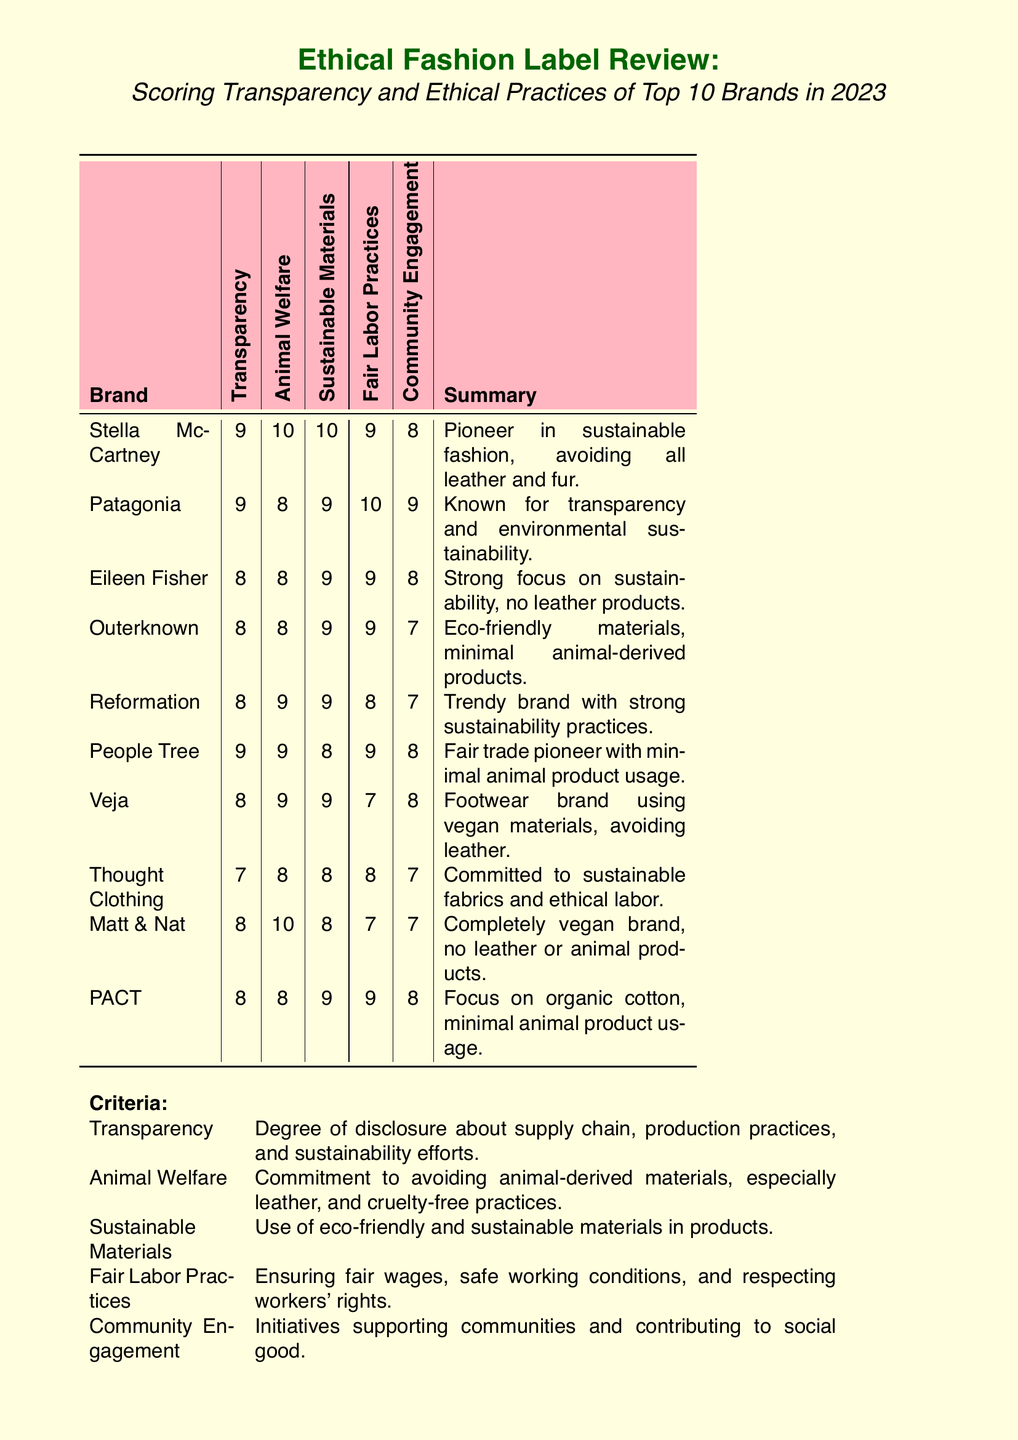What is the highest score for Animal Welfare? The highest score for Animal Welfare among the brands listed in the document is 10, awarded to Stella McCartney and Matt & Nat.
Answer: 10 Which brand is a pioneer in sustainable fashion? The document states that Stella McCartney is a pioneer in sustainable fashion, making it clear in the summary provided.
Answer: Stella McCartney What is the average score for Sustainable Materials among the brands listed? By averaging the scores for Sustainable Materials: (10+9+9+9+9+8+9+8+9+8) / 10 = 8.9.
Answer: 8.9 Which brand uses completely vegan materials and avoids leather? The document specifies that Matt & Nat is a completely vegan brand with no leather or animal products.
Answer: Matt & Nat What does the score for Fair Labor Practices of Patagonia indicate? Patagonia's score for Fair Labor Practices is 10, indicating excellent fair labor practices according to the scoring criteria.
Answer: 10 How many brands scored an 8 for Transparency? The document shows that 5 brands scored an 8 for Transparency: Eileen Fisher, Outerknown, Reformation, Veja, and PACT.
Answer: 5 What criteria has a score of 7 for Thought Clothing? Thought Clothing has a score of 7 for Community Engagement according to the scoring table in the document.
Answer: Community Engagement Which brand has the lowest score overall? The scores suggest that Thought Clothing has the lowest score overall, with a score of 7 in Transparency and various scores in other categories.
Answer: Thought Clothing What is the focus of PACT regarding materials? The document indicates that PACT focuses on organic cotton with minimal animal product usage.
Answer: Organic cotton 